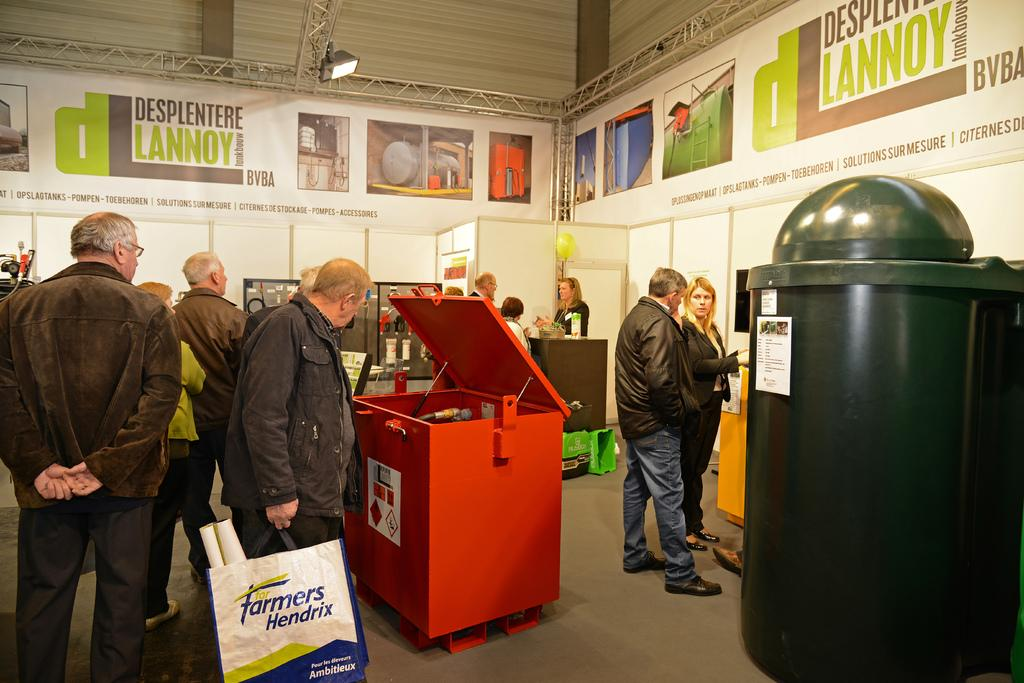<image>
Write a terse but informative summary of the picture. Several people are in a room with banners that say Desplentere Lannoy. 